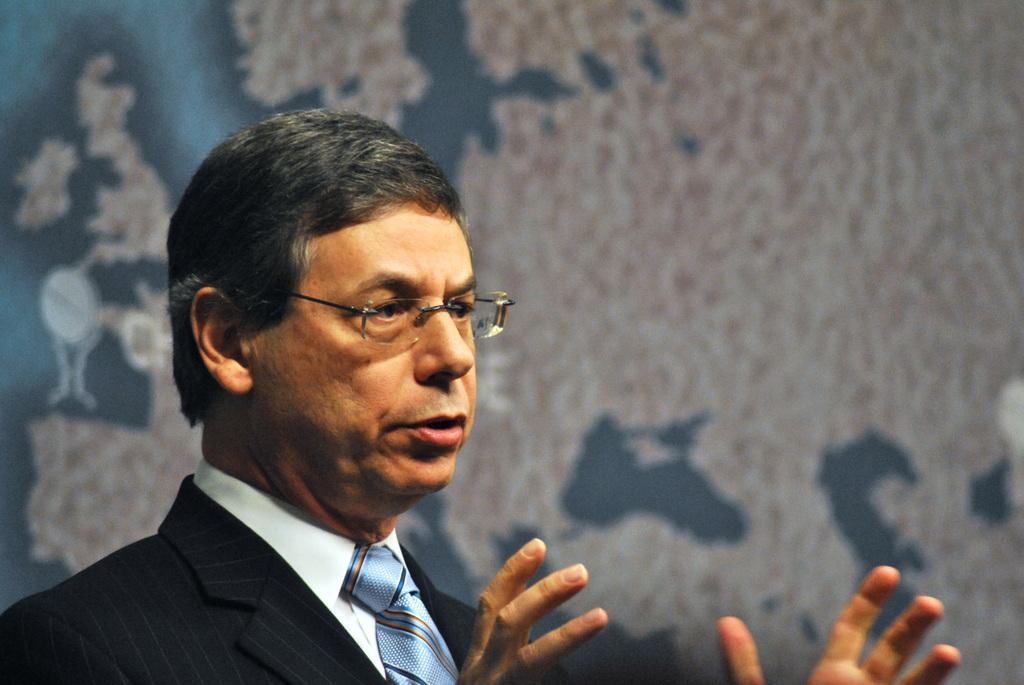Describe this image in one or two sentences. In the foreground of the image there is a person wearing a suit. In the background of the image there is a wall with some design on it. 